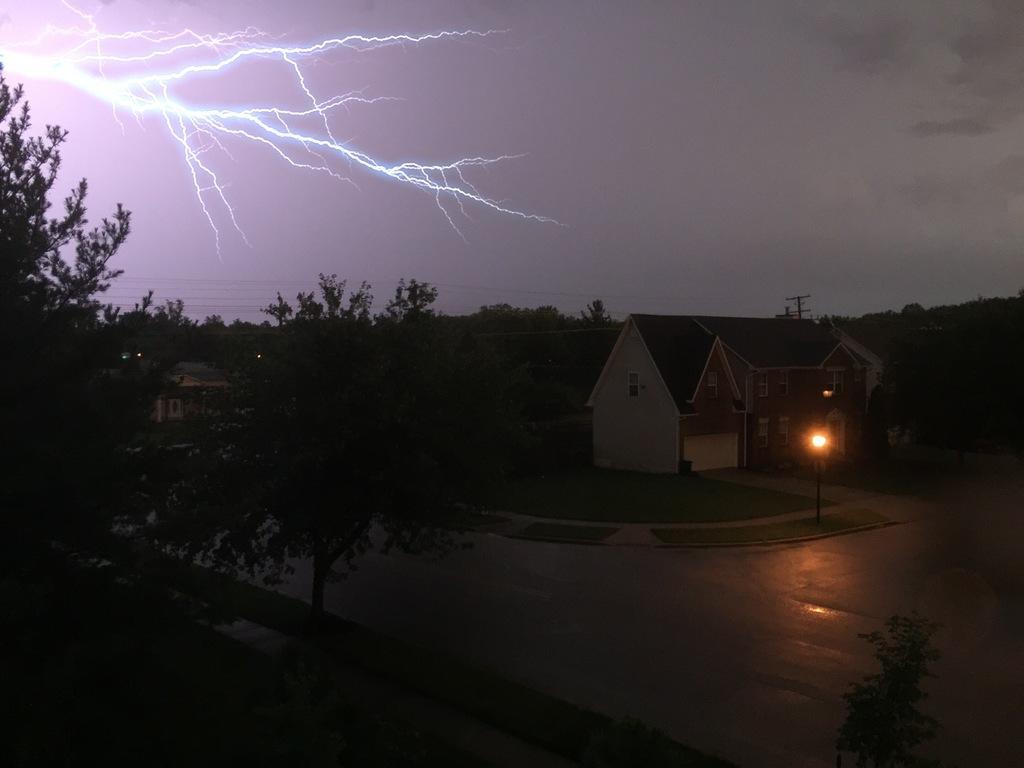Describe this image in one or two sentences. In this image, we can see houses. We can see some poles. Among them, we can see a light pole. We can see the ground. We can see some grass. There are a few trees. We can see the sky with thunder. 